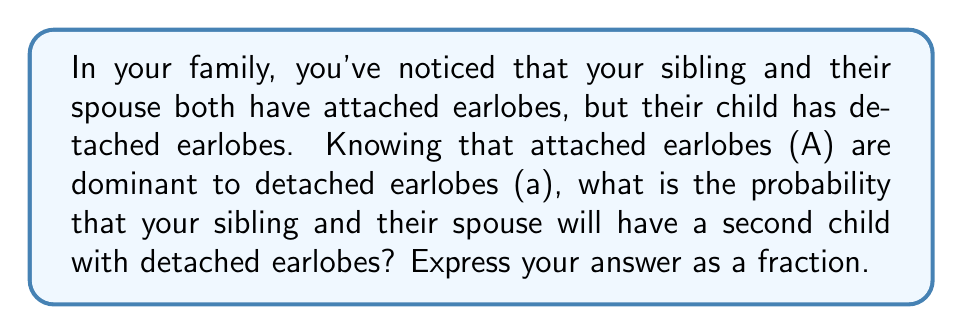Help me with this question. To solve this problem, we need to follow these steps:

1) First, let's determine the genotypes of your sibling and their spouse. Since they both have attached earlobes (dominant trait) but produced a child with detached earlobes (recessive trait), they must both be heterozygous (Aa).

2) The Punnett square for this cross would be:

   $$
   \begin{array}{c|cc}
     & A & a \\
   \hline
   A & AA & Aa \\
   a & Aa & aa
   \end{array}
   $$

3) From this Punnett square, we can see that:
   - AA: 1/4 chance (attached earlobes)
   - Aa: 1/2 chance (attached earlobes)
   - aa: 1/4 chance (detached earlobes)

4) The probability of having a child with detached earlobes is represented by the aa genotype, which has a 1/4 chance of occurring.

5) Therefore, the probability that your sibling and their spouse will have a second child with detached earlobes is 1/4.

This problem illustrates how recessive traits can appear in offspring even when both parents show the dominant trait, a common occurrence in multi-generational genetic inheritance patterns.
Answer: $\frac{1}{4}$ 